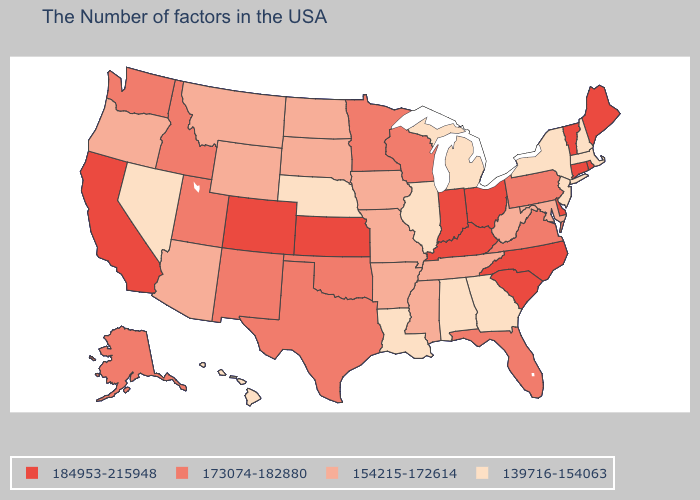What is the lowest value in states that border New Jersey?
Quick response, please. 139716-154063. Does Illinois have the lowest value in the USA?
Write a very short answer. Yes. Which states have the lowest value in the USA?
Keep it brief. Massachusetts, New Hampshire, New York, New Jersey, Georgia, Michigan, Alabama, Illinois, Louisiana, Nebraska, Nevada, Hawaii. What is the value of California?
Concise answer only. 184953-215948. Among the states that border New Mexico , which have the highest value?
Short answer required. Colorado. Name the states that have a value in the range 154215-172614?
Keep it brief. Maryland, West Virginia, Tennessee, Mississippi, Missouri, Arkansas, Iowa, South Dakota, North Dakota, Wyoming, Montana, Arizona, Oregon. What is the value of California?
Answer briefly. 184953-215948. Does Washington have the same value as Nebraska?
Quick response, please. No. What is the value of Rhode Island?
Quick response, please. 184953-215948. What is the value of Georgia?
Concise answer only. 139716-154063. What is the highest value in the MidWest ?
Keep it brief. 184953-215948. What is the value of Wyoming?
Give a very brief answer. 154215-172614. What is the value of Maine?
Answer briefly. 184953-215948. Does the first symbol in the legend represent the smallest category?
Give a very brief answer. No. Name the states that have a value in the range 154215-172614?
Be succinct. Maryland, West Virginia, Tennessee, Mississippi, Missouri, Arkansas, Iowa, South Dakota, North Dakota, Wyoming, Montana, Arizona, Oregon. 